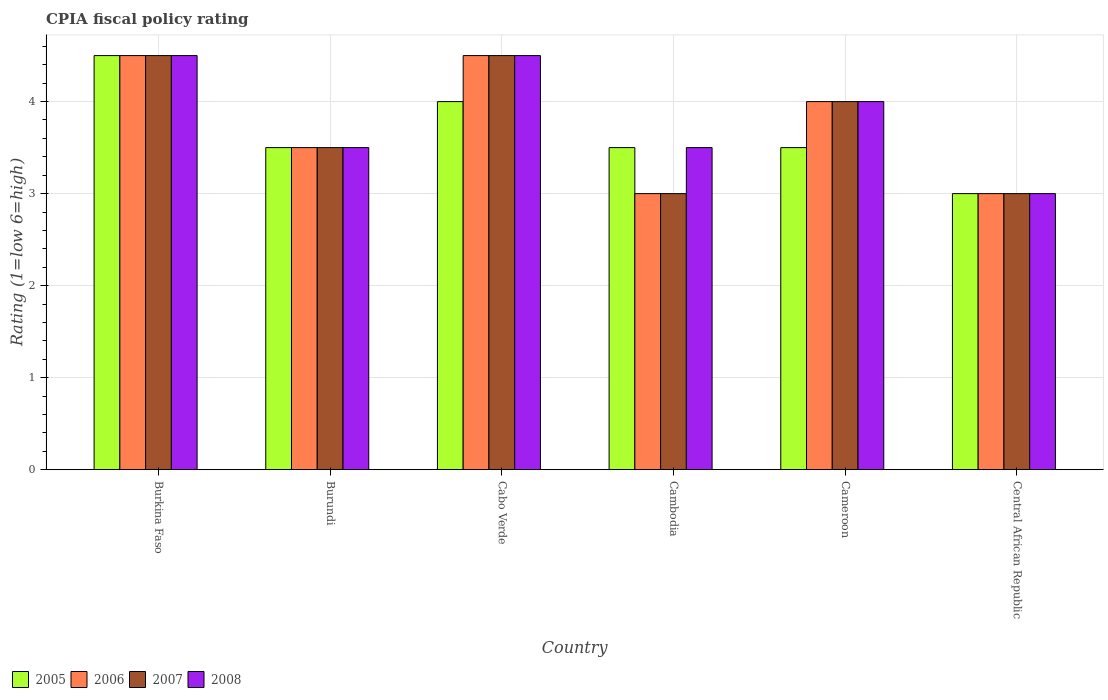How many different coloured bars are there?
Provide a succinct answer. 4. How many bars are there on the 4th tick from the right?
Your answer should be compact. 4. What is the label of the 5th group of bars from the left?
Offer a terse response. Cameroon. What is the CPIA rating in 2006 in Cambodia?
Give a very brief answer. 3. In which country was the CPIA rating in 2007 maximum?
Ensure brevity in your answer.  Burkina Faso. In which country was the CPIA rating in 2008 minimum?
Provide a short and direct response. Central African Republic. What is the difference between the CPIA rating in 2008 in Burundi and that in Cameroon?
Your response must be concise. -0.5. What is the average CPIA rating in 2005 per country?
Provide a succinct answer. 3.67. What is the difference between the CPIA rating of/in 2005 and CPIA rating of/in 2008 in Burkina Faso?
Your response must be concise. 0. What is the ratio of the CPIA rating in 2005 in Cambodia to that in Central African Republic?
Your answer should be very brief. 1.17. What does the 1st bar from the left in Cameroon represents?
Give a very brief answer. 2005. What does the 1st bar from the right in Burkina Faso represents?
Make the answer very short. 2008. Is it the case that in every country, the sum of the CPIA rating in 2007 and CPIA rating in 2008 is greater than the CPIA rating in 2005?
Keep it short and to the point. Yes. How many bars are there?
Your answer should be very brief. 24. Are all the bars in the graph horizontal?
Your answer should be compact. No. How many countries are there in the graph?
Provide a short and direct response. 6. What is the difference between two consecutive major ticks on the Y-axis?
Offer a terse response. 1. Are the values on the major ticks of Y-axis written in scientific E-notation?
Give a very brief answer. No. Does the graph contain any zero values?
Provide a succinct answer. No. Where does the legend appear in the graph?
Ensure brevity in your answer.  Bottom left. How many legend labels are there?
Make the answer very short. 4. What is the title of the graph?
Provide a succinct answer. CPIA fiscal policy rating. What is the Rating (1=low 6=high) of 2005 in Burkina Faso?
Your response must be concise. 4.5. What is the Rating (1=low 6=high) in 2006 in Burkina Faso?
Offer a very short reply. 4.5. What is the Rating (1=low 6=high) in 2007 in Burkina Faso?
Your answer should be very brief. 4.5. What is the Rating (1=low 6=high) of 2007 in Burundi?
Offer a terse response. 3.5. What is the Rating (1=low 6=high) of 2008 in Cabo Verde?
Offer a terse response. 4.5. What is the Rating (1=low 6=high) of 2005 in Cambodia?
Provide a succinct answer. 3.5. What is the Rating (1=low 6=high) in 2006 in Cambodia?
Offer a terse response. 3. What is the Rating (1=low 6=high) of 2005 in Cameroon?
Ensure brevity in your answer.  3.5. What is the Rating (1=low 6=high) in 2007 in Cameroon?
Offer a terse response. 4. What is the Rating (1=low 6=high) in 2008 in Central African Republic?
Your response must be concise. 3. Across all countries, what is the maximum Rating (1=low 6=high) in 2005?
Your answer should be compact. 4.5. Across all countries, what is the maximum Rating (1=low 6=high) of 2006?
Ensure brevity in your answer.  4.5. Across all countries, what is the maximum Rating (1=low 6=high) of 2008?
Your answer should be very brief. 4.5. What is the total Rating (1=low 6=high) in 2006 in the graph?
Give a very brief answer. 22.5. What is the total Rating (1=low 6=high) in 2008 in the graph?
Offer a very short reply. 23. What is the difference between the Rating (1=low 6=high) of 2007 in Burkina Faso and that in Burundi?
Ensure brevity in your answer.  1. What is the difference between the Rating (1=low 6=high) of 2005 in Burkina Faso and that in Cabo Verde?
Offer a very short reply. 0.5. What is the difference between the Rating (1=low 6=high) of 2008 in Burkina Faso and that in Cabo Verde?
Your answer should be very brief. 0. What is the difference between the Rating (1=low 6=high) of 2005 in Burkina Faso and that in Cambodia?
Offer a very short reply. 1. What is the difference between the Rating (1=low 6=high) in 2008 in Burkina Faso and that in Cambodia?
Offer a very short reply. 1. What is the difference between the Rating (1=low 6=high) of 2005 in Burkina Faso and that in Cameroon?
Keep it short and to the point. 1. What is the difference between the Rating (1=low 6=high) in 2008 in Burkina Faso and that in Central African Republic?
Offer a terse response. 1.5. What is the difference between the Rating (1=low 6=high) in 2006 in Burundi and that in Cabo Verde?
Your answer should be compact. -1. What is the difference between the Rating (1=low 6=high) in 2008 in Burundi and that in Cabo Verde?
Keep it short and to the point. -1. What is the difference between the Rating (1=low 6=high) in 2005 in Burundi and that in Cambodia?
Your response must be concise. 0. What is the difference between the Rating (1=low 6=high) in 2007 in Burundi and that in Cambodia?
Give a very brief answer. 0.5. What is the difference between the Rating (1=low 6=high) in 2008 in Burundi and that in Cambodia?
Keep it short and to the point. 0. What is the difference between the Rating (1=low 6=high) in 2005 in Burundi and that in Cameroon?
Offer a very short reply. 0. What is the difference between the Rating (1=low 6=high) in 2006 in Burundi and that in Cameroon?
Ensure brevity in your answer.  -0.5. What is the difference between the Rating (1=low 6=high) in 2008 in Burundi and that in Central African Republic?
Make the answer very short. 0.5. What is the difference between the Rating (1=low 6=high) of 2007 in Cabo Verde and that in Cambodia?
Offer a very short reply. 1.5. What is the difference between the Rating (1=low 6=high) in 2008 in Cabo Verde and that in Cambodia?
Keep it short and to the point. 1. What is the difference between the Rating (1=low 6=high) of 2006 in Cabo Verde and that in Cameroon?
Keep it short and to the point. 0.5. What is the difference between the Rating (1=low 6=high) of 2005 in Cabo Verde and that in Central African Republic?
Offer a very short reply. 1. What is the difference between the Rating (1=low 6=high) of 2006 in Cabo Verde and that in Central African Republic?
Offer a very short reply. 1.5. What is the difference between the Rating (1=low 6=high) of 2007 in Cabo Verde and that in Central African Republic?
Offer a terse response. 1.5. What is the difference between the Rating (1=low 6=high) in 2008 in Cabo Verde and that in Central African Republic?
Offer a very short reply. 1.5. What is the difference between the Rating (1=low 6=high) of 2005 in Cambodia and that in Cameroon?
Provide a short and direct response. 0. What is the difference between the Rating (1=low 6=high) in 2006 in Cambodia and that in Cameroon?
Your answer should be very brief. -1. What is the difference between the Rating (1=low 6=high) of 2007 in Cambodia and that in Cameroon?
Provide a succinct answer. -1. What is the difference between the Rating (1=low 6=high) in 2005 in Cambodia and that in Central African Republic?
Offer a terse response. 0.5. What is the difference between the Rating (1=low 6=high) of 2006 in Cambodia and that in Central African Republic?
Your answer should be compact. 0. What is the difference between the Rating (1=low 6=high) in 2005 in Cameroon and that in Central African Republic?
Provide a succinct answer. 0.5. What is the difference between the Rating (1=low 6=high) of 2006 in Cameroon and that in Central African Republic?
Ensure brevity in your answer.  1. What is the difference between the Rating (1=low 6=high) in 2008 in Cameroon and that in Central African Republic?
Offer a very short reply. 1. What is the difference between the Rating (1=low 6=high) of 2005 in Burkina Faso and the Rating (1=low 6=high) of 2006 in Burundi?
Provide a short and direct response. 1. What is the difference between the Rating (1=low 6=high) of 2005 in Burkina Faso and the Rating (1=low 6=high) of 2007 in Burundi?
Your answer should be compact. 1. What is the difference between the Rating (1=low 6=high) of 2006 in Burkina Faso and the Rating (1=low 6=high) of 2008 in Burundi?
Offer a very short reply. 1. What is the difference between the Rating (1=low 6=high) in 2005 in Burkina Faso and the Rating (1=low 6=high) in 2006 in Cabo Verde?
Provide a short and direct response. 0. What is the difference between the Rating (1=low 6=high) in 2005 in Burkina Faso and the Rating (1=low 6=high) in 2007 in Cabo Verde?
Provide a succinct answer. 0. What is the difference between the Rating (1=low 6=high) of 2006 in Burkina Faso and the Rating (1=low 6=high) of 2007 in Cabo Verde?
Make the answer very short. 0. What is the difference between the Rating (1=low 6=high) of 2006 in Burkina Faso and the Rating (1=low 6=high) of 2008 in Cabo Verde?
Your response must be concise. 0. What is the difference between the Rating (1=low 6=high) in 2005 in Burkina Faso and the Rating (1=low 6=high) in 2006 in Cambodia?
Give a very brief answer. 1.5. What is the difference between the Rating (1=low 6=high) in 2005 in Burkina Faso and the Rating (1=low 6=high) in 2008 in Cambodia?
Provide a succinct answer. 1. What is the difference between the Rating (1=low 6=high) in 2006 in Burkina Faso and the Rating (1=low 6=high) in 2007 in Cambodia?
Your answer should be compact. 1.5. What is the difference between the Rating (1=low 6=high) in 2007 in Burkina Faso and the Rating (1=low 6=high) in 2008 in Cambodia?
Make the answer very short. 1. What is the difference between the Rating (1=low 6=high) in 2005 in Burkina Faso and the Rating (1=low 6=high) in 2006 in Cameroon?
Give a very brief answer. 0.5. What is the difference between the Rating (1=low 6=high) in 2005 in Burkina Faso and the Rating (1=low 6=high) in 2007 in Cameroon?
Offer a terse response. 0.5. What is the difference between the Rating (1=low 6=high) of 2007 in Burkina Faso and the Rating (1=low 6=high) of 2008 in Cameroon?
Provide a short and direct response. 0.5. What is the difference between the Rating (1=low 6=high) of 2005 in Burkina Faso and the Rating (1=low 6=high) of 2007 in Central African Republic?
Provide a short and direct response. 1.5. What is the difference between the Rating (1=low 6=high) in 2005 in Burkina Faso and the Rating (1=low 6=high) in 2008 in Central African Republic?
Your answer should be compact. 1.5. What is the difference between the Rating (1=low 6=high) of 2006 in Burkina Faso and the Rating (1=low 6=high) of 2008 in Central African Republic?
Provide a succinct answer. 1.5. What is the difference between the Rating (1=low 6=high) in 2007 in Burkina Faso and the Rating (1=low 6=high) in 2008 in Central African Republic?
Your answer should be very brief. 1.5. What is the difference between the Rating (1=low 6=high) of 2005 in Burundi and the Rating (1=low 6=high) of 2007 in Cabo Verde?
Make the answer very short. -1. What is the difference between the Rating (1=low 6=high) of 2005 in Burundi and the Rating (1=low 6=high) of 2008 in Cabo Verde?
Keep it short and to the point. -1. What is the difference between the Rating (1=low 6=high) in 2007 in Burundi and the Rating (1=low 6=high) in 2008 in Cabo Verde?
Provide a succinct answer. -1. What is the difference between the Rating (1=low 6=high) of 2005 in Burundi and the Rating (1=low 6=high) of 2007 in Cambodia?
Ensure brevity in your answer.  0.5. What is the difference between the Rating (1=low 6=high) in 2006 in Burundi and the Rating (1=low 6=high) in 2008 in Cambodia?
Your answer should be very brief. 0. What is the difference between the Rating (1=low 6=high) of 2005 in Burundi and the Rating (1=low 6=high) of 2006 in Cameroon?
Provide a short and direct response. -0.5. What is the difference between the Rating (1=low 6=high) of 2007 in Burundi and the Rating (1=low 6=high) of 2008 in Cameroon?
Provide a succinct answer. -0.5. What is the difference between the Rating (1=low 6=high) in 2005 in Burundi and the Rating (1=low 6=high) in 2006 in Central African Republic?
Keep it short and to the point. 0.5. What is the difference between the Rating (1=low 6=high) of 2005 in Burundi and the Rating (1=low 6=high) of 2008 in Central African Republic?
Provide a succinct answer. 0.5. What is the difference between the Rating (1=low 6=high) of 2007 in Burundi and the Rating (1=low 6=high) of 2008 in Central African Republic?
Offer a very short reply. 0.5. What is the difference between the Rating (1=low 6=high) of 2005 in Cabo Verde and the Rating (1=low 6=high) of 2006 in Cambodia?
Make the answer very short. 1. What is the difference between the Rating (1=low 6=high) of 2005 in Cabo Verde and the Rating (1=low 6=high) of 2007 in Cambodia?
Give a very brief answer. 1. What is the difference between the Rating (1=low 6=high) in 2006 in Cabo Verde and the Rating (1=low 6=high) in 2007 in Cambodia?
Your answer should be very brief. 1.5. What is the difference between the Rating (1=low 6=high) of 2007 in Cabo Verde and the Rating (1=low 6=high) of 2008 in Cambodia?
Provide a short and direct response. 1. What is the difference between the Rating (1=low 6=high) of 2005 in Cabo Verde and the Rating (1=low 6=high) of 2008 in Cameroon?
Keep it short and to the point. 0. What is the difference between the Rating (1=low 6=high) of 2006 in Cabo Verde and the Rating (1=low 6=high) of 2008 in Cameroon?
Your response must be concise. 0.5. What is the difference between the Rating (1=low 6=high) of 2007 in Cabo Verde and the Rating (1=low 6=high) of 2008 in Cameroon?
Make the answer very short. 0.5. What is the difference between the Rating (1=low 6=high) of 2006 in Cabo Verde and the Rating (1=low 6=high) of 2007 in Central African Republic?
Provide a short and direct response. 1.5. What is the difference between the Rating (1=low 6=high) in 2006 in Cambodia and the Rating (1=low 6=high) in 2007 in Cameroon?
Offer a terse response. -1. What is the difference between the Rating (1=low 6=high) in 2005 in Cambodia and the Rating (1=low 6=high) in 2008 in Central African Republic?
Give a very brief answer. 0.5. What is the difference between the Rating (1=low 6=high) of 2006 in Cambodia and the Rating (1=low 6=high) of 2008 in Central African Republic?
Ensure brevity in your answer.  0. What is the difference between the Rating (1=low 6=high) in 2007 in Cambodia and the Rating (1=low 6=high) in 2008 in Central African Republic?
Your answer should be very brief. 0. What is the difference between the Rating (1=low 6=high) of 2005 in Cameroon and the Rating (1=low 6=high) of 2007 in Central African Republic?
Keep it short and to the point. 0.5. What is the difference between the Rating (1=low 6=high) of 2007 in Cameroon and the Rating (1=low 6=high) of 2008 in Central African Republic?
Provide a short and direct response. 1. What is the average Rating (1=low 6=high) of 2005 per country?
Offer a very short reply. 3.67. What is the average Rating (1=low 6=high) in 2006 per country?
Your answer should be compact. 3.75. What is the average Rating (1=low 6=high) in 2007 per country?
Your answer should be compact. 3.75. What is the average Rating (1=low 6=high) in 2008 per country?
Your answer should be compact. 3.83. What is the difference between the Rating (1=low 6=high) of 2006 and Rating (1=low 6=high) of 2007 in Burkina Faso?
Make the answer very short. 0. What is the difference between the Rating (1=low 6=high) of 2006 and Rating (1=low 6=high) of 2008 in Burkina Faso?
Make the answer very short. 0. What is the difference between the Rating (1=low 6=high) in 2007 and Rating (1=low 6=high) in 2008 in Burkina Faso?
Provide a short and direct response. 0. What is the difference between the Rating (1=low 6=high) of 2005 and Rating (1=low 6=high) of 2008 in Burundi?
Ensure brevity in your answer.  0. What is the difference between the Rating (1=low 6=high) in 2006 and Rating (1=low 6=high) in 2007 in Burundi?
Ensure brevity in your answer.  0. What is the difference between the Rating (1=low 6=high) in 2006 and Rating (1=low 6=high) in 2008 in Burundi?
Your response must be concise. 0. What is the difference between the Rating (1=low 6=high) in 2007 and Rating (1=low 6=high) in 2008 in Burundi?
Give a very brief answer. 0. What is the difference between the Rating (1=low 6=high) in 2005 and Rating (1=low 6=high) in 2007 in Cabo Verde?
Give a very brief answer. -0.5. What is the difference between the Rating (1=low 6=high) of 2006 and Rating (1=low 6=high) of 2008 in Cabo Verde?
Offer a terse response. 0. What is the difference between the Rating (1=low 6=high) of 2005 and Rating (1=low 6=high) of 2006 in Cambodia?
Provide a short and direct response. 0.5. What is the difference between the Rating (1=low 6=high) of 2005 and Rating (1=low 6=high) of 2007 in Cambodia?
Provide a succinct answer. 0.5. What is the difference between the Rating (1=low 6=high) in 2006 and Rating (1=low 6=high) in 2007 in Cambodia?
Give a very brief answer. 0. What is the difference between the Rating (1=low 6=high) in 2006 and Rating (1=low 6=high) in 2008 in Cambodia?
Offer a very short reply. -0.5. What is the difference between the Rating (1=low 6=high) of 2007 and Rating (1=low 6=high) of 2008 in Cameroon?
Your response must be concise. 0. What is the difference between the Rating (1=low 6=high) in 2005 and Rating (1=low 6=high) in 2008 in Central African Republic?
Your answer should be compact. 0. What is the difference between the Rating (1=low 6=high) in 2006 and Rating (1=low 6=high) in 2008 in Central African Republic?
Make the answer very short. 0. What is the difference between the Rating (1=low 6=high) in 2007 and Rating (1=low 6=high) in 2008 in Central African Republic?
Offer a terse response. 0. What is the ratio of the Rating (1=low 6=high) in 2005 in Burkina Faso to that in Burundi?
Offer a very short reply. 1.29. What is the ratio of the Rating (1=low 6=high) of 2008 in Burkina Faso to that in Burundi?
Provide a succinct answer. 1.29. What is the ratio of the Rating (1=low 6=high) in 2005 in Burkina Faso to that in Cabo Verde?
Give a very brief answer. 1.12. What is the ratio of the Rating (1=low 6=high) in 2007 in Burkina Faso to that in Cabo Verde?
Offer a very short reply. 1. What is the ratio of the Rating (1=low 6=high) of 2006 in Burkina Faso to that in Cambodia?
Offer a terse response. 1.5. What is the ratio of the Rating (1=low 6=high) in 2007 in Burkina Faso to that in Cambodia?
Offer a very short reply. 1.5. What is the ratio of the Rating (1=low 6=high) of 2008 in Burkina Faso to that in Cambodia?
Ensure brevity in your answer.  1.29. What is the ratio of the Rating (1=low 6=high) of 2005 in Burkina Faso to that in Cameroon?
Make the answer very short. 1.29. What is the ratio of the Rating (1=low 6=high) in 2007 in Burkina Faso to that in Central African Republic?
Your answer should be compact. 1.5. What is the ratio of the Rating (1=low 6=high) in 2005 in Burundi to that in Cabo Verde?
Make the answer very short. 0.88. What is the ratio of the Rating (1=low 6=high) of 2005 in Burundi to that in Cambodia?
Make the answer very short. 1. What is the ratio of the Rating (1=low 6=high) in 2006 in Burundi to that in Cambodia?
Keep it short and to the point. 1.17. What is the ratio of the Rating (1=low 6=high) of 2008 in Burundi to that in Cambodia?
Provide a succinct answer. 1. What is the ratio of the Rating (1=low 6=high) in 2005 in Burundi to that in Cameroon?
Make the answer very short. 1. What is the ratio of the Rating (1=low 6=high) in 2006 in Burundi to that in Cameroon?
Your response must be concise. 0.88. What is the ratio of the Rating (1=low 6=high) in 2006 in Burundi to that in Central African Republic?
Offer a terse response. 1.17. What is the ratio of the Rating (1=low 6=high) in 2007 in Burundi to that in Central African Republic?
Keep it short and to the point. 1.17. What is the ratio of the Rating (1=low 6=high) of 2008 in Burundi to that in Central African Republic?
Make the answer very short. 1.17. What is the ratio of the Rating (1=low 6=high) of 2007 in Cabo Verde to that in Cambodia?
Provide a short and direct response. 1.5. What is the ratio of the Rating (1=low 6=high) of 2008 in Cabo Verde to that in Cambodia?
Your answer should be compact. 1.29. What is the ratio of the Rating (1=low 6=high) in 2005 in Cabo Verde to that in Cameroon?
Give a very brief answer. 1.14. What is the ratio of the Rating (1=low 6=high) of 2006 in Cabo Verde to that in Cameroon?
Offer a very short reply. 1.12. What is the ratio of the Rating (1=low 6=high) of 2007 in Cabo Verde to that in Cameroon?
Your answer should be compact. 1.12. What is the ratio of the Rating (1=low 6=high) of 2008 in Cabo Verde to that in Cameroon?
Your answer should be compact. 1.12. What is the ratio of the Rating (1=low 6=high) of 2007 in Cabo Verde to that in Central African Republic?
Your response must be concise. 1.5. What is the ratio of the Rating (1=low 6=high) in 2008 in Cabo Verde to that in Central African Republic?
Offer a terse response. 1.5. What is the ratio of the Rating (1=low 6=high) in 2005 in Cambodia to that in Cameroon?
Ensure brevity in your answer.  1. What is the ratio of the Rating (1=low 6=high) of 2006 in Cambodia to that in Cameroon?
Your response must be concise. 0.75. What is the ratio of the Rating (1=low 6=high) of 2007 in Cambodia to that in Cameroon?
Provide a succinct answer. 0.75. What is the ratio of the Rating (1=low 6=high) of 2006 in Cambodia to that in Central African Republic?
Offer a very short reply. 1. What is the ratio of the Rating (1=low 6=high) in 2007 in Cambodia to that in Central African Republic?
Provide a short and direct response. 1. What is the ratio of the Rating (1=low 6=high) of 2008 in Cambodia to that in Central African Republic?
Your answer should be very brief. 1.17. What is the ratio of the Rating (1=low 6=high) in 2006 in Cameroon to that in Central African Republic?
Keep it short and to the point. 1.33. What is the ratio of the Rating (1=low 6=high) in 2008 in Cameroon to that in Central African Republic?
Offer a terse response. 1.33. What is the difference between the highest and the second highest Rating (1=low 6=high) of 2006?
Give a very brief answer. 0. What is the difference between the highest and the lowest Rating (1=low 6=high) of 2006?
Keep it short and to the point. 1.5. What is the difference between the highest and the lowest Rating (1=low 6=high) in 2007?
Your answer should be compact. 1.5. 